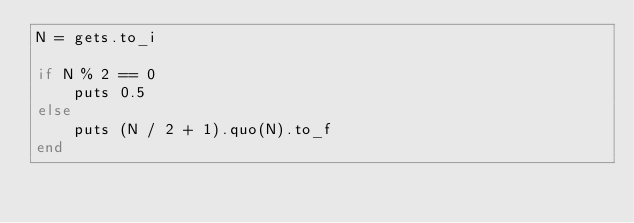Convert code to text. <code><loc_0><loc_0><loc_500><loc_500><_Ruby_>N = gets.to_i

if N % 2 == 0
    puts 0.5
else
    puts (N / 2 + 1).quo(N).to_f
end
</code> 